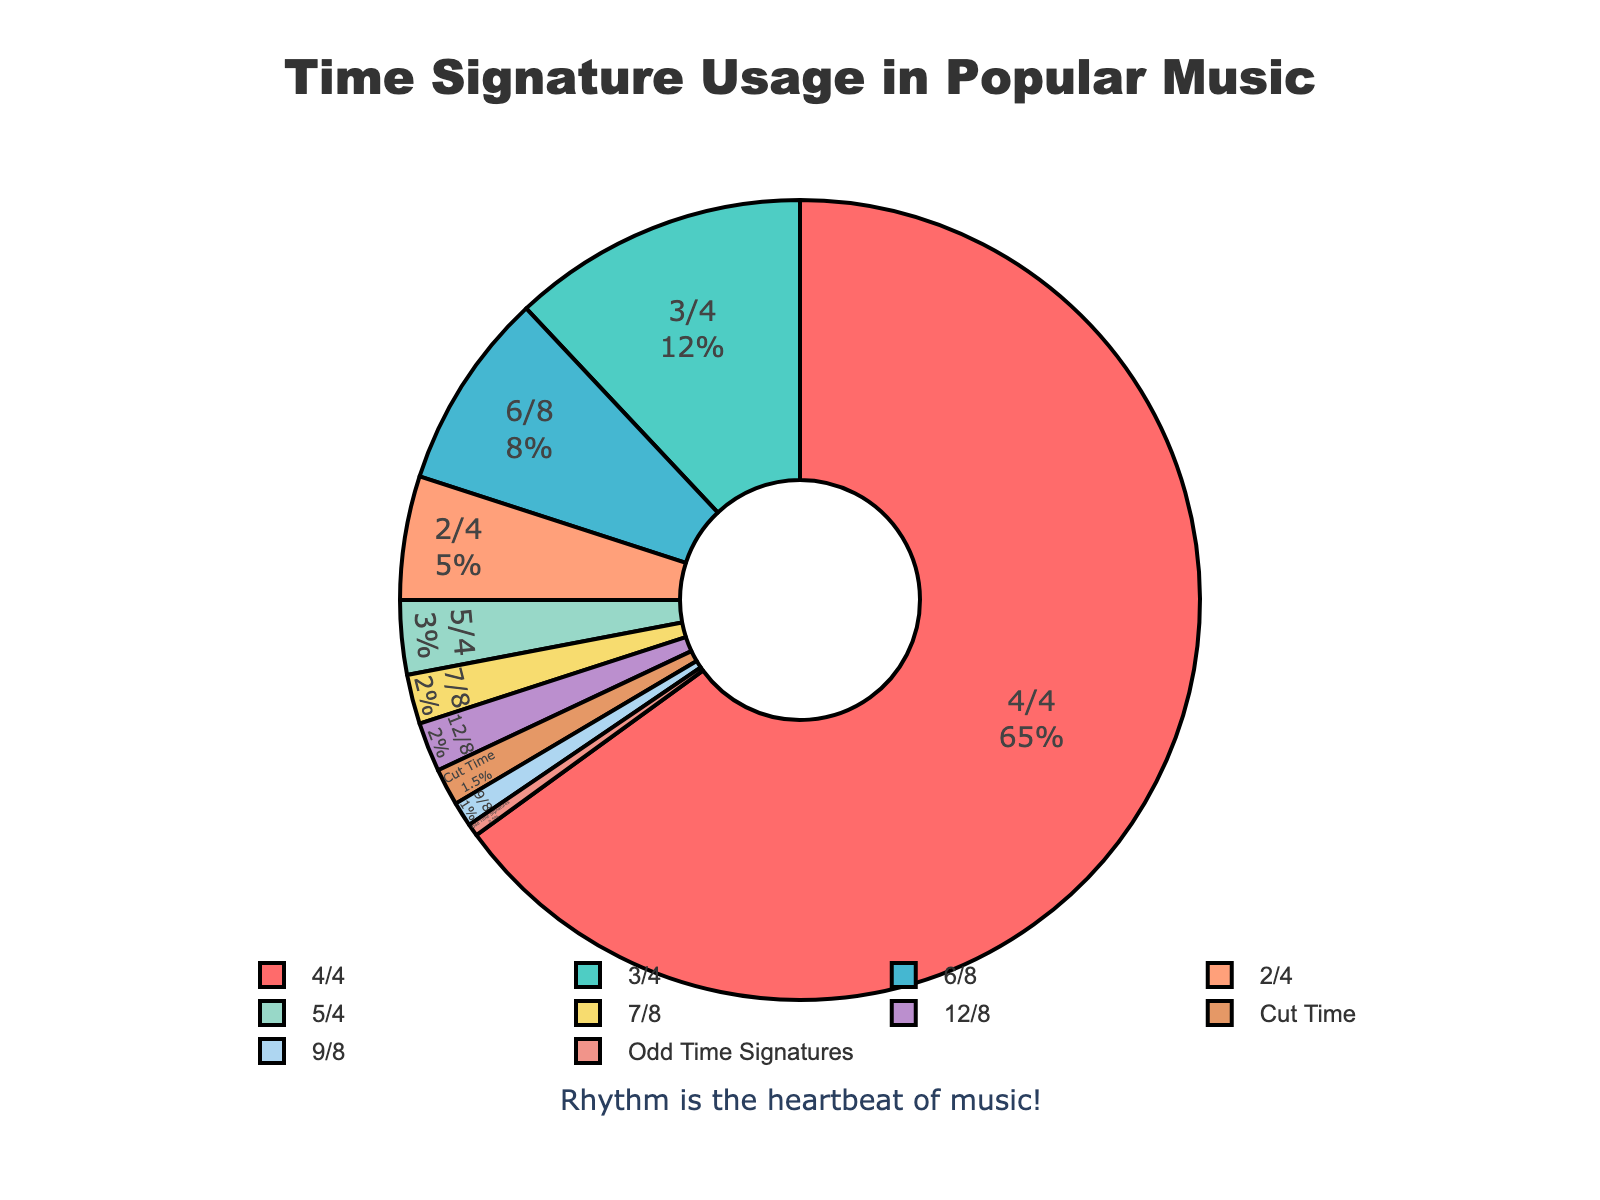Which time signature has the highest usage in popular music? Look at the pie chart and identify the time signature with the largest segment. The 4/4 time signature has the biggest slice.
Answer: 4/4 What is the total percentage of songs using odd time signatures (5/4, 7/8, 9/8, and 'Odd Time Signatures')? Adding the percentages: 5/4 (3%) + 7/8 (2%) + 9/8 (1%) + Odd Time Signatures (0.5%) = 3% + 2% + 1% + 0.5% = 6.5%
Answer: 6.5% Which time signatures have equal usage in the figure, and what is their percentage? Identify the time signatures with the same segment sizes on the pie chart. The 7/8 and 12/8 time signatures both have equal slices and each represents 2%.
Answer: 7/8 and 12/8, 2% Compare the usage of 3/4 and 6/8 time signatures. Which one is more common, and by how much? Compare the percentage values of the 3/4 and 6/8 segments. The 3/4 segment is larger with 12% compared to the 6/8 segment with 8%. Therefore, the 3/4 is more common by 4%.
Answer: 3/4 by 4% What's the combined percentage of usage for 3/4 and Cut Time signatures? Add the percentage values of 3/4 (12%) and Cut Time (1.5%). 12% + 1.5% = 13.5%
Answer: 13.5% How much larger is the percentage of 4/4 compared to 2/4? Subtract the percentage for 2/4 from the percentage for 4/4. 65% - 5% = 60%
Answer: 60% What percentage of songs do not use 4/4, 3/4, or 6/8 time signatures? Sum the percentages of all other time signatures and subtract from 100%. 100% - (65% + 12% + 8%) = 100% - 85% = 15%.
Answer: 15% Which segment is visually represented by the color green? Look for the segment in the pie chart that is colored green and note the corresponding time signature. The 3/4 time signature segment is green.
Answer: 3/4 What is the least common time signature, and what percentage does it represent? Identify the smallest segment on the pie chart, which represents the least common time signature. The 'Odd Time Signatures' segment is the smallest at 0.5%.
Answer: Odd Time Signatures, 0.5% How many time signatures have a usage percentage less than 5%? Count the segments on the pie chart that are less than 5%. Those are: 2/4, 5/4, 7/8, 12/8, Cut Time, 9/8, Odd Time Signatures, making a total of 7.
Answer: 7 